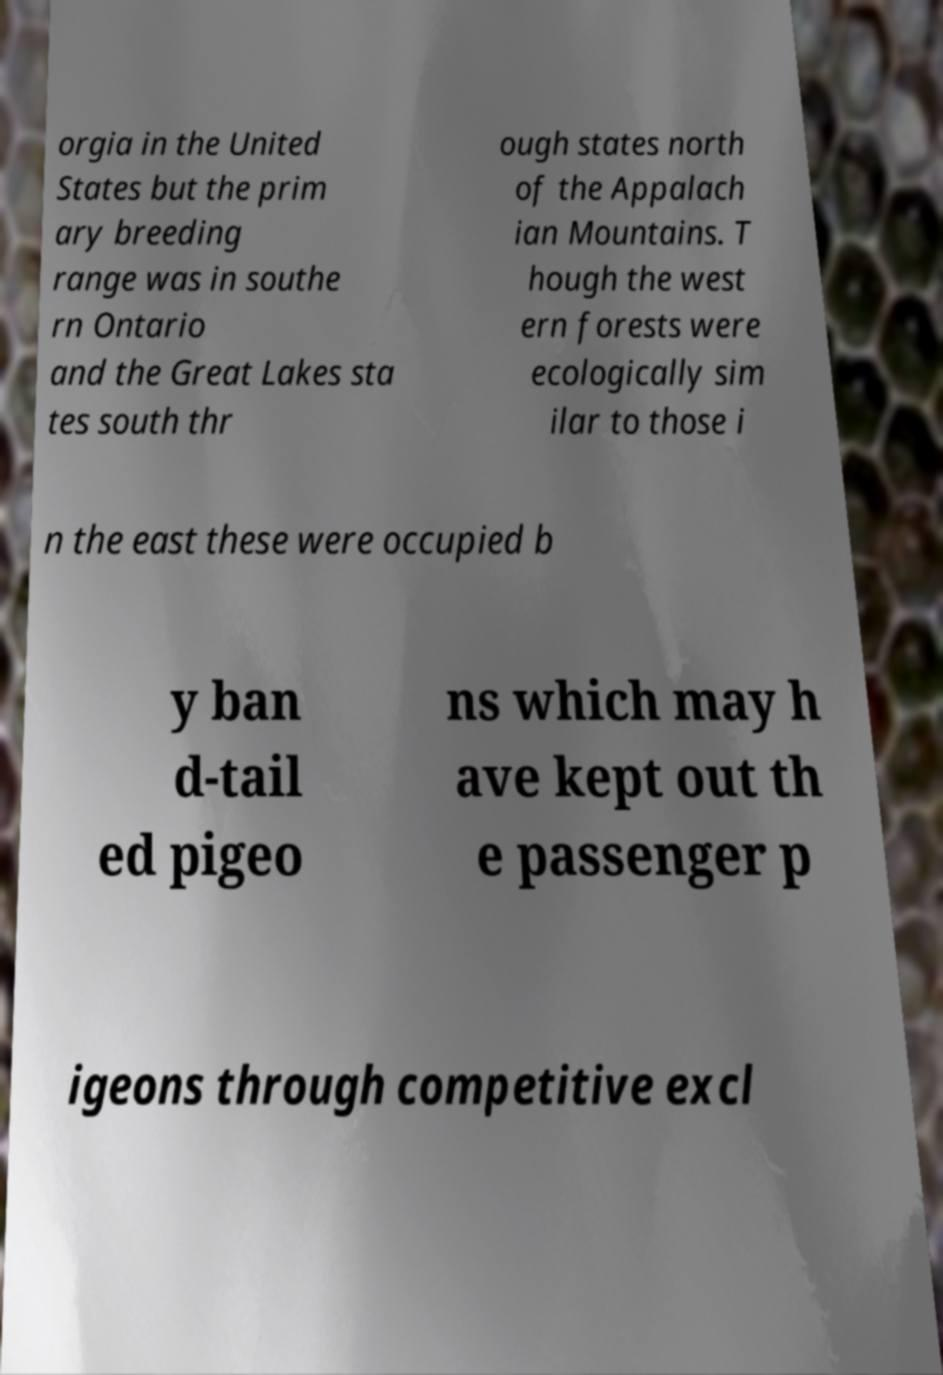Can you read and provide the text displayed in the image?This photo seems to have some interesting text. Can you extract and type it out for me? orgia in the United States but the prim ary breeding range was in southe rn Ontario and the Great Lakes sta tes south thr ough states north of the Appalach ian Mountains. T hough the west ern forests were ecologically sim ilar to those i n the east these were occupied b y ban d-tail ed pigeo ns which may h ave kept out th e passenger p igeons through competitive excl 